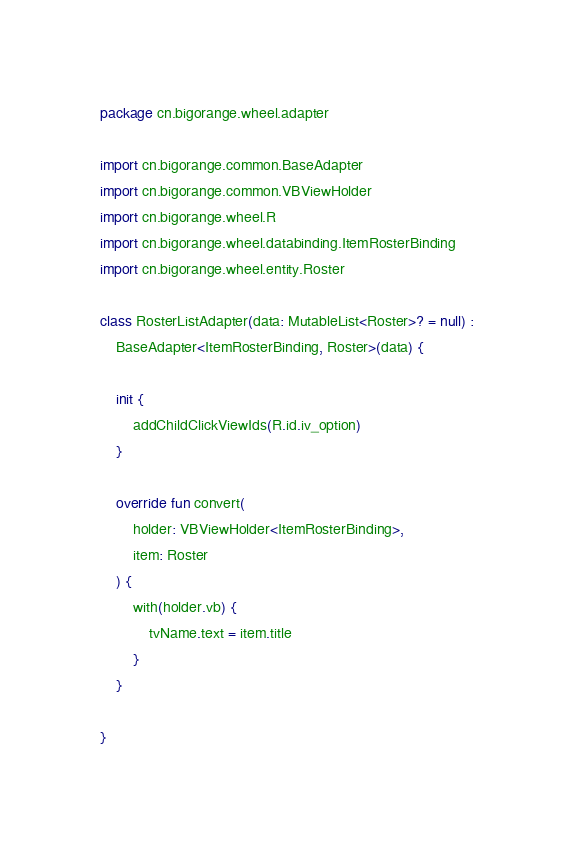<code> <loc_0><loc_0><loc_500><loc_500><_Kotlin_>package cn.bigorange.wheel.adapter

import cn.bigorange.common.BaseAdapter
import cn.bigorange.common.VBViewHolder
import cn.bigorange.wheel.R
import cn.bigorange.wheel.databinding.ItemRosterBinding
import cn.bigorange.wheel.entity.Roster

class RosterListAdapter(data: MutableList<Roster>? = null) :
    BaseAdapter<ItemRosterBinding, Roster>(data) {

    init {
        addChildClickViewIds(R.id.iv_option)
    }

    override fun convert(
        holder: VBViewHolder<ItemRosterBinding>,
        item: Roster
    ) {
        with(holder.vb) {
            tvName.text = item.title
        }
    }

}</code> 